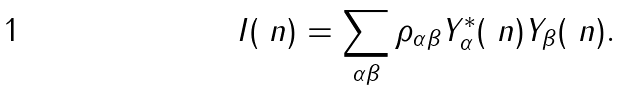Convert formula to latex. <formula><loc_0><loc_0><loc_500><loc_500>I ( \ n ) = \sum _ { \alpha \beta } \rho _ { \alpha \beta } Y _ { \alpha } ^ { * } ( \ n ) Y _ { \beta } ( \ n ) .</formula> 